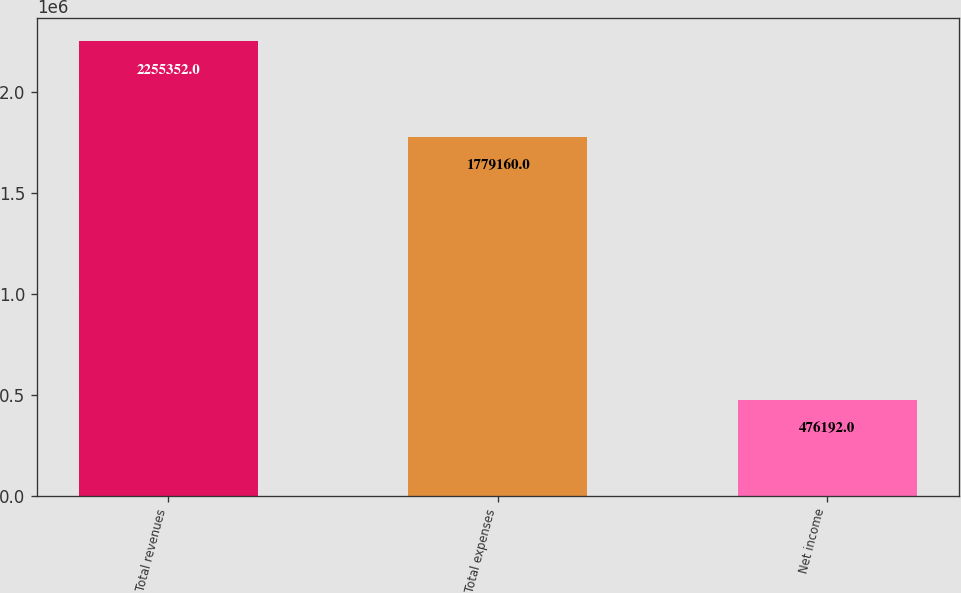<chart> <loc_0><loc_0><loc_500><loc_500><bar_chart><fcel>Total revenues<fcel>Total expenses<fcel>Net income<nl><fcel>2.25535e+06<fcel>1.77916e+06<fcel>476192<nl></chart> 